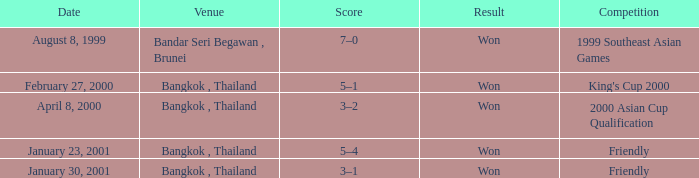What was the score from the king's cup 2000? 5–1. 